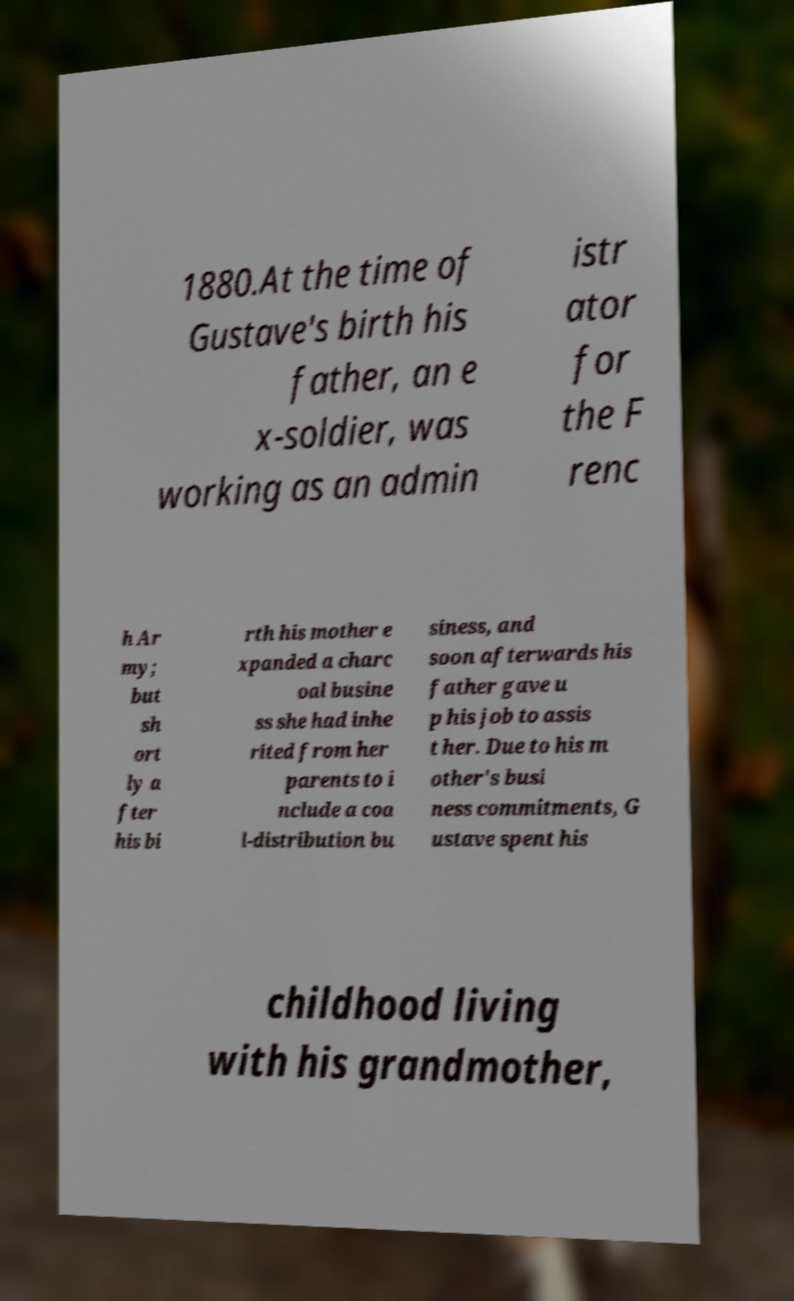Please identify and transcribe the text found in this image. 1880.At the time of Gustave's birth his father, an e x-soldier, was working as an admin istr ator for the F renc h Ar my; but sh ort ly a fter his bi rth his mother e xpanded a charc oal busine ss she had inhe rited from her parents to i nclude a coa l-distribution bu siness, and soon afterwards his father gave u p his job to assis t her. Due to his m other's busi ness commitments, G ustave spent his childhood living with his grandmother, 